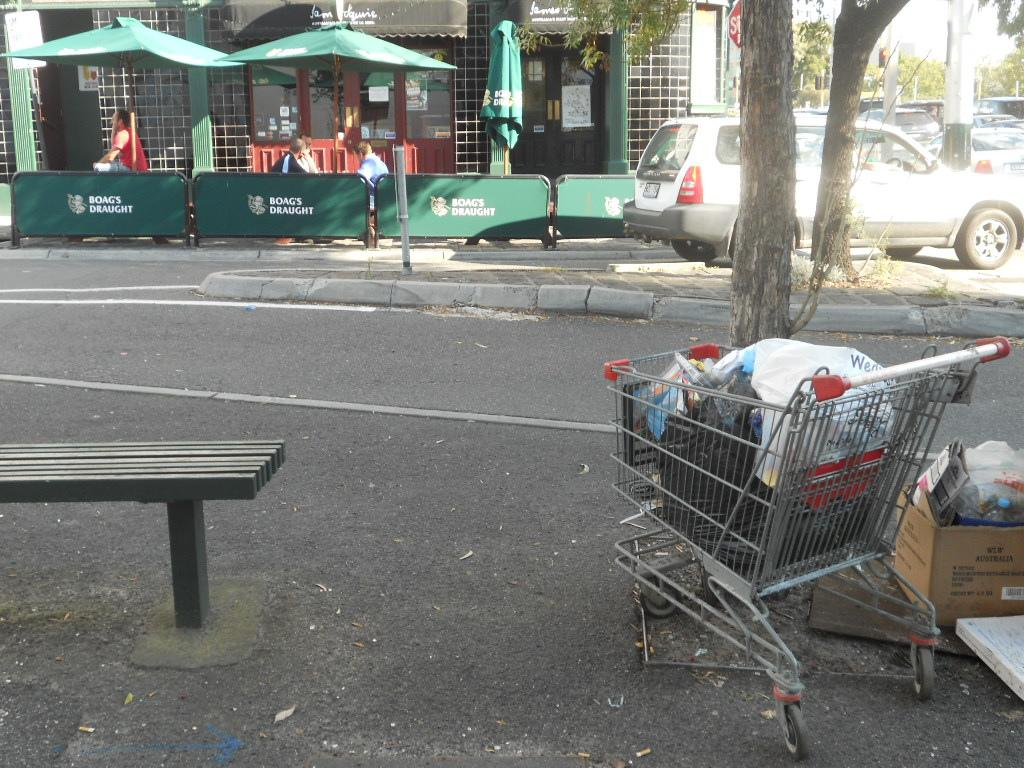Mention the most prominent objects and their positions in the image. A full, grey shopping cart at the center, a man in red shirt sitting at the left, a green umbrella shading a café at the top, and a white hatchback automobile parked at the right. Mention any unusual elements in the image. There is a stop sign partially hidden behind a tree, and a beer advertisement is visible on green fabric, adding extra visual elements to the scene. Describe the image by focusing on the transportation elements present. A white hatchback car is parked on a dark grey road marked with white lines, while a full grey shopping cart sits nearby, and a green and white barricade appears further away. Describe the objects in the image with a focus on their functions. A green umbrella provides shelter at an outdoor café, a full shopping cart contains various items, a man sits and relaxes outside, and a white hatchback car is parked along the street. List the main objects and secondary objects in the image separately. Main objects: full shopping cart, green umbrella, man in red shirt, white hatchback car. Secondary objects: dark grey road, white lines, green and white barricade. Provide a brief overview of the main objects and their interactions within the image. A full shopping cart with various items is near a tree, while a man in a red shirt sits outside under a big green umbrella at a café, with a silver hatchback car parked on the dark grey road. Highlight the outdoor gathering as well as the transportation aspects of the image. A man sits outdoors under a green umbrella near a café, while the nearby street boasts a white hatchback car parked and a full shopping cart, indicating a lively urban scene. Summarize the image in the context of an urban environment and outdoor activity. In a busy urban setting, a man enjoys sitting outside under a large green umbrella at a café, as a parked hatchback car and a full shopping cart fill the streetscape. Write a description of the scene, focusing on the colors and objects present in the image. A vibrant scene with a green umbrella sheltering a café, a red-shirted man sitting, white lines on the dark grey road, a parked silver hatchback car, a green and white barricade, and a grey shopping cart filled with items. Provide a concise narrative of the image as if describing it to someone on the phone. So, there's this scene with a man wearing a red shirt, just sitting outside enjoying the shade from a big green umbrella, and there's a silver car and a packed shopping cart nearby. 